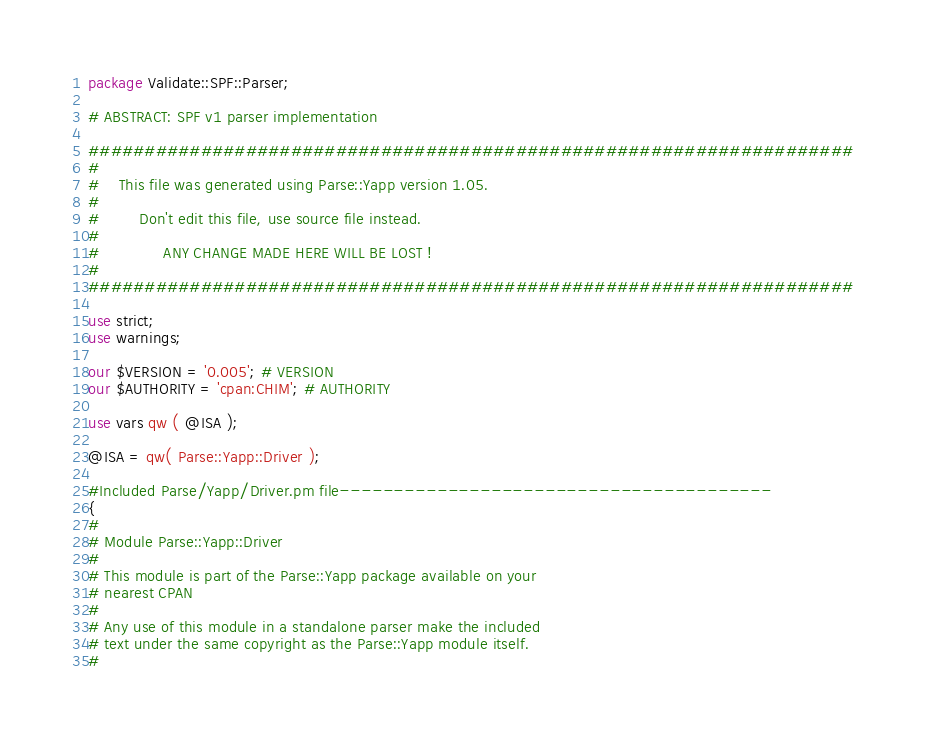<code> <loc_0><loc_0><loc_500><loc_500><_Perl_>package Validate::SPF::Parser;

# ABSTRACT: SPF v1 parser implementation

####################################################################
#
#    This file was generated using Parse::Yapp version 1.05.
#
#        Don't edit this file, use source file instead.
#
#             ANY CHANGE MADE HERE WILL BE LOST !
#
####################################################################

use strict;
use warnings;

our $VERSION = '0.005'; # VERSION
our $AUTHORITY = 'cpan:CHIM'; # AUTHORITY

use vars qw ( @ISA );

@ISA = qw( Parse::Yapp::Driver );

#Included Parse/Yapp/Driver.pm file----------------------------------------
{
#
# Module Parse::Yapp::Driver
#
# This module is part of the Parse::Yapp package available on your
# nearest CPAN
#
# Any use of this module in a standalone parser make the included
# text under the same copyright as the Parse::Yapp module itself.
#</code> 